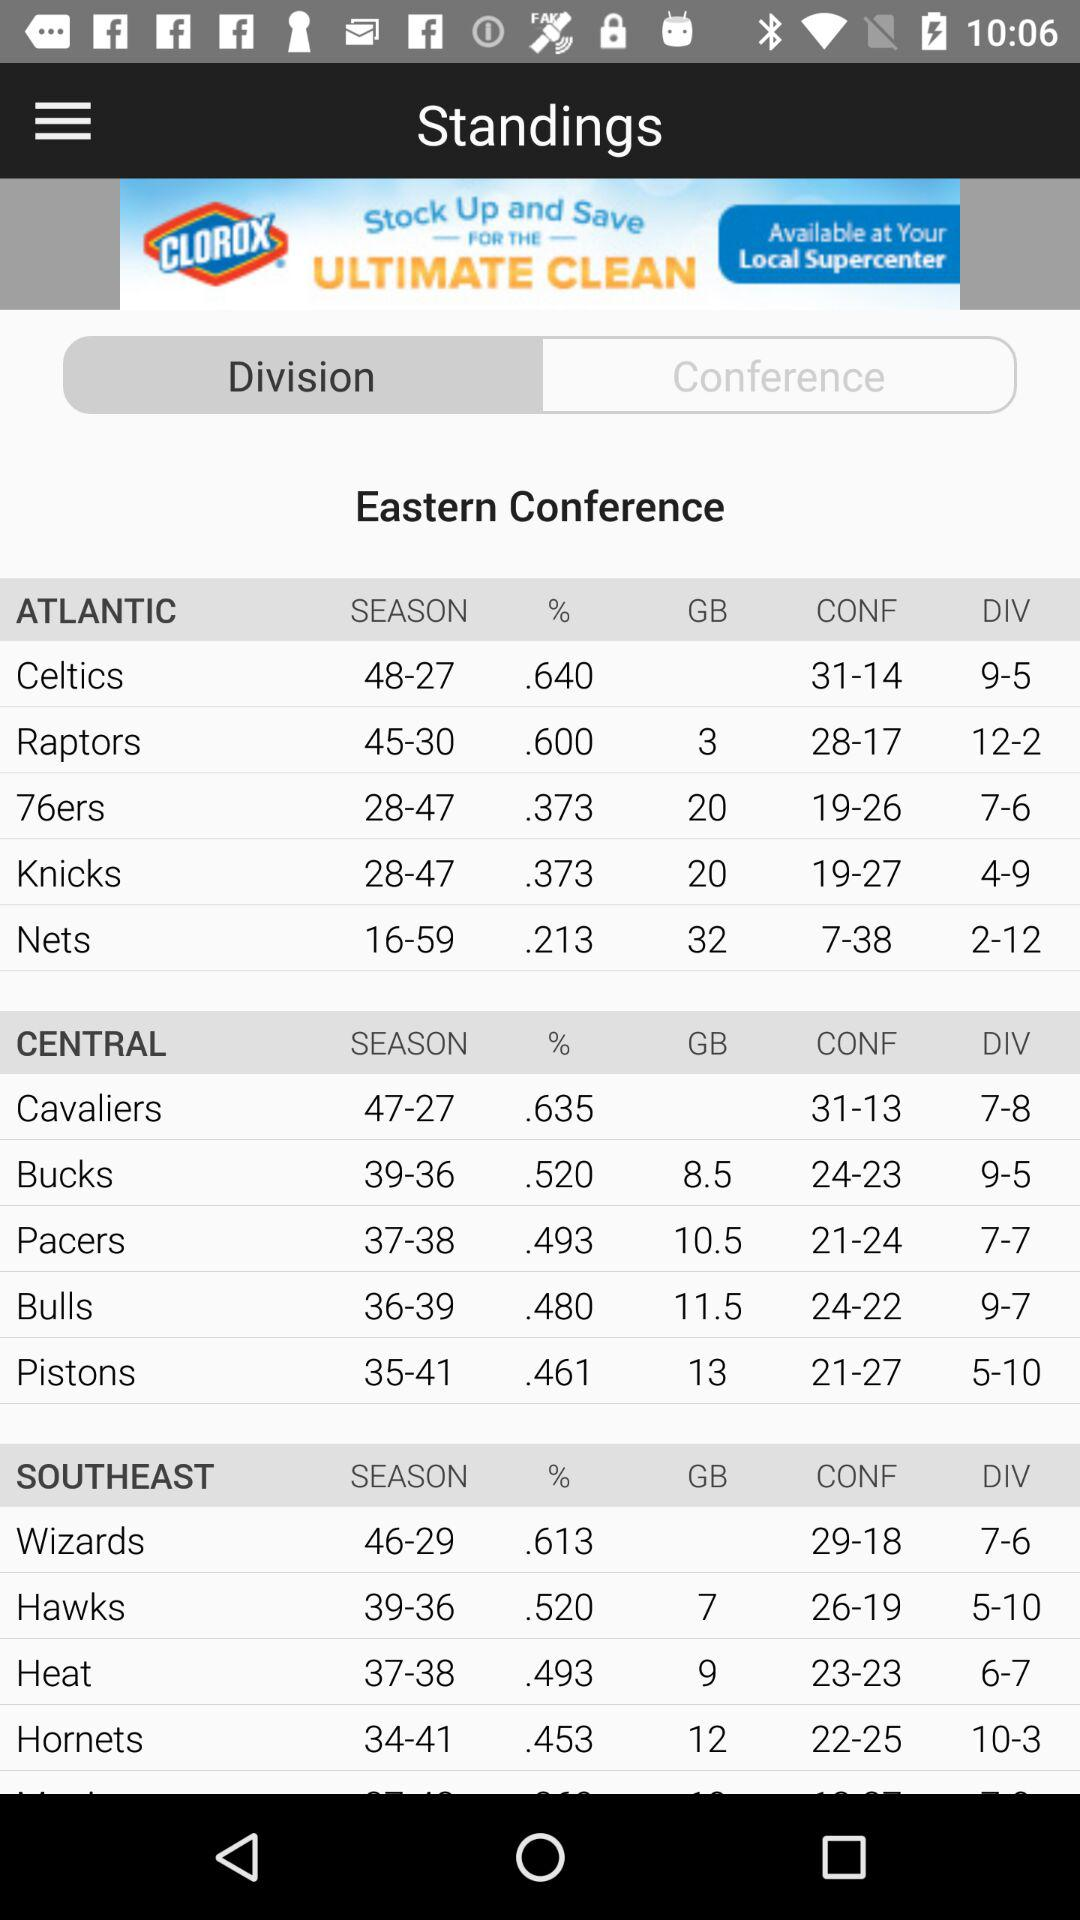What is the division of "Knicks"? The division is 4-9. 